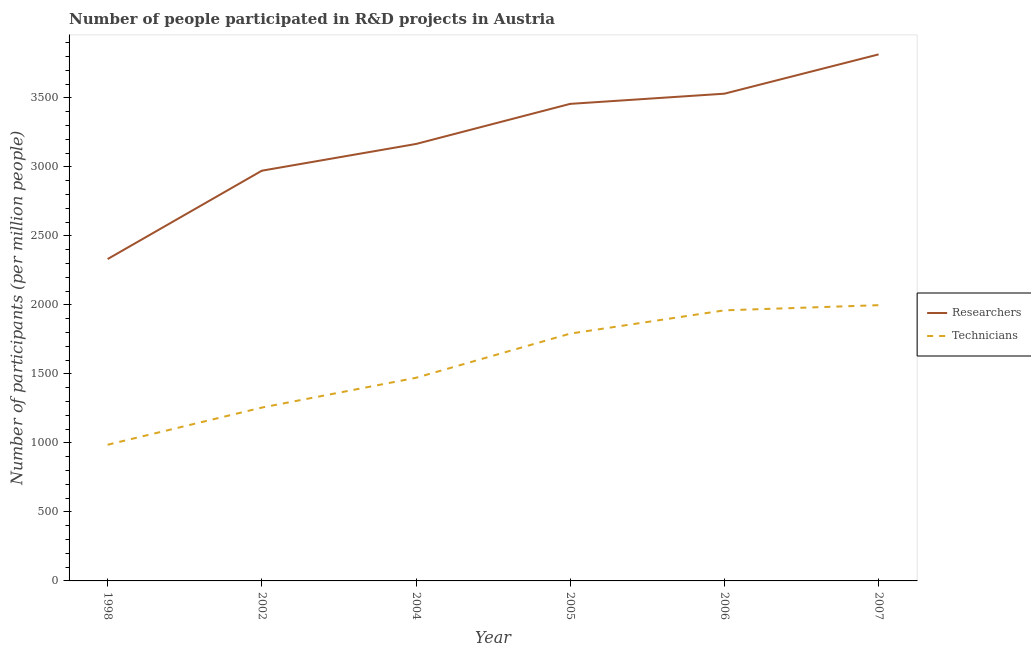Does the line corresponding to number of technicians intersect with the line corresponding to number of researchers?
Make the answer very short. No. Is the number of lines equal to the number of legend labels?
Your answer should be very brief. Yes. What is the number of technicians in 2004?
Your answer should be compact. 1472.18. Across all years, what is the maximum number of researchers?
Make the answer very short. 3815.74. Across all years, what is the minimum number of researchers?
Your answer should be compact. 2332.6. What is the total number of technicians in the graph?
Provide a succinct answer. 9466.98. What is the difference between the number of technicians in 2004 and that in 2006?
Keep it short and to the point. -488.71. What is the difference between the number of technicians in 2004 and the number of researchers in 1998?
Offer a very short reply. -860.42. What is the average number of technicians per year?
Keep it short and to the point. 1577.83. In the year 2005, what is the difference between the number of technicians and number of researchers?
Your answer should be very brief. -1664.84. What is the ratio of the number of researchers in 1998 to that in 2007?
Offer a very short reply. 0.61. Is the number of researchers in 1998 less than that in 2004?
Your answer should be compact. Yes. Is the difference between the number of researchers in 2002 and 2004 greater than the difference between the number of technicians in 2002 and 2004?
Give a very brief answer. Yes. What is the difference between the highest and the second highest number of technicians?
Your answer should be compact. 37.42. What is the difference between the highest and the lowest number of researchers?
Keep it short and to the point. 1483.15. In how many years, is the number of technicians greater than the average number of technicians taken over all years?
Keep it short and to the point. 3. Is the sum of the number of technicians in 2005 and 2006 greater than the maximum number of researchers across all years?
Offer a very short reply. No. Is the number of technicians strictly less than the number of researchers over the years?
Your response must be concise. Yes. How many lines are there?
Your answer should be very brief. 2. How many years are there in the graph?
Offer a very short reply. 6. What is the difference between two consecutive major ticks on the Y-axis?
Provide a succinct answer. 500. Does the graph contain any zero values?
Your answer should be compact. No. Does the graph contain grids?
Keep it short and to the point. No. Where does the legend appear in the graph?
Give a very brief answer. Center right. What is the title of the graph?
Your response must be concise. Number of people participated in R&D projects in Austria. Does "State government" appear as one of the legend labels in the graph?
Your response must be concise. No. What is the label or title of the X-axis?
Give a very brief answer. Year. What is the label or title of the Y-axis?
Make the answer very short. Number of participants (per million people). What is the Number of participants (per million people) of Researchers in 1998?
Provide a succinct answer. 2332.6. What is the Number of participants (per million people) of Technicians in 1998?
Offer a terse response. 987.02. What is the Number of participants (per million people) of Researchers in 2002?
Give a very brief answer. 2972.89. What is the Number of participants (per million people) in Technicians in 2002?
Ensure brevity in your answer.  1256.23. What is the Number of participants (per million people) in Researchers in 2004?
Your answer should be compact. 3166.57. What is the Number of participants (per million people) in Technicians in 2004?
Provide a succinct answer. 1472.18. What is the Number of participants (per million people) of Researchers in 2005?
Keep it short and to the point. 3457.21. What is the Number of participants (per million people) in Technicians in 2005?
Your answer should be compact. 1792.36. What is the Number of participants (per million people) of Researchers in 2006?
Keep it short and to the point. 3530.95. What is the Number of participants (per million people) in Technicians in 2006?
Provide a succinct answer. 1960.89. What is the Number of participants (per million people) of Researchers in 2007?
Your answer should be very brief. 3815.74. What is the Number of participants (per million people) in Technicians in 2007?
Make the answer very short. 1998.31. Across all years, what is the maximum Number of participants (per million people) of Researchers?
Offer a very short reply. 3815.74. Across all years, what is the maximum Number of participants (per million people) in Technicians?
Give a very brief answer. 1998.31. Across all years, what is the minimum Number of participants (per million people) in Researchers?
Offer a terse response. 2332.6. Across all years, what is the minimum Number of participants (per million people) of Technicians?
Provide a succinct answer. 987.02. What is the total Number of participants (per million people) of Researchers in the graph?
Your response must be concise. 1.93e+04. What is the total Number of participants (per million people) in Technicians in the graph?
Provide a succinct answer. 9466.98. What is the difference between the Number of participants (per million people) in Researchers in 1998 and that in 2002?
Offer a terse response. -640.29. What is the difference between the Number of participants (per million people) in Technicians in 1998 and that in 2002?
Offer a very short reply. -269.21. What is the difference between the Number of participants (per million people) of Researchers in 1998 and that in 2004?
Give a very brief answer. -833.98. What is the difference between the Number of participants (per million people) in Technicians in 1998 and that in 2004?
Make the answer very short. -485.16. What is the difference between the Number of participants (per million people) in Researchers in 1998 and that in 2005?
Your answer should be very brief. -1124.61. What is the difference between the Number of participants (per million people) of Technicians in 1998 and that in 2005?
Your answer should be very brief. -805.34. What is the difference between the Number of participants (per million people) in Researchers in 1998 and that in 2006?
Make the answer very short. -1198.35. What is the difference between the Number of participants (per million people) of Technicians in 1998 and that in 2006?
Provide a short and direct response. -973.87. What is the difference between the Number of participants (per million people) in Researchers in 1998 and that in 2007?
Keep it short and to the point. -1483.15. What is the difference between the Number of participants (per million people) of Technicians in 1998 and that in 2007?
Provide a short and direct response. -1011.29. What is the difference between the Number of participants (per million people) in Researchers in 2002 and that in 2004?
Your answer should be very brief. -193.68. What is the difference between the Number of participants (per million people) in Technicians in 2002 and that in 2004?
Keep it short and to the point. -215.95. What is the difference between the Number of participants (per million people) of Researchers in 2002 and that in 2005?
Provide a succinct answer. -484.32. What is the difference between the Number of participants (per million people) in Technicians in 2002 and that in 2005?
Offer a terse response. -536.13. What is the difference between the Number of participants (per million people) of Researchers in 2002 and that in 2006?
Keep it short and to the point. -558.06. What is the difference between the Number of participants (per million people) in Technicians in 2002 and that in 2006?
Make the answer very short. -704.66. What is the difference between the Number of participants (per million people) in Researchers in 2002 and that in 2007?
Give a very brief answer. -842.85. What is the difference between the Number of participants (per million people) in Technicians in 2002 and that in 2007?
Offer a very short reply. -742.08. What is the difference between the Number of participants (per million people) of Researchers in 2004 and that in 2005?
Provide a short and direct response. -290.63. What is the difference between the Number of participants (per million people) of Technicians in 2004 and that in 2005?
Offer a very short reply. -320.18. What is the difference between the Number of participants (per million people) in Researchers in 2004 and that in 2006?
Your response must be concise. -364.37. What is the difference between the Number of participants (per million people) of Technicians in 2004 and that in 2006?
Give a very brief answer. -488.71. What is the difference between the Number of participants (per million people) of Researchers in 2004 and that in 2007?
Your response must be concise. -649.17. What is the difference between the Number of participants (per million people) of Technicians in 2004 and that in 2007?
Provide a short and direct response. -526.13. What is the difference between the Number of participants (per million people) of Researchers in 2005 and that in 2006?
Provide a succinct answer. -73.74. What is the difference between the Number of participants (per million people) in Technicians in 2005 and that in 2006?
Keep it short and to the point. -168.53. What is the difference between the Number of participants (per million people) in Researchers in 2005 and that in 2007?
Provide a short and direct response. -358.54. What is the difference between the Number of participants (per million people) in Technicians in 2005 and that in 2007?
Give a very brief answer. -205.95. What is the difference between the Number of participants (per million people) in Researchers in 2006 and that in 2007?
Offer a terse response. -284.8. What is the difference between the Number of participants (per million people) of Technicians in 2006 and that in 2007?
Provide a short and direct response. -37.42. What is the difference between the Number of participants (per million people) in Researchers in 1998 and the Number of participants (per million people) in Technicians in 2002?
Offer a very short reply. 1076.37. What is the difference between the Number of participants (per million people) in Researchers in 1998 and the Number of participants (per million people) in Technicians in 2004?
Your answer should be compact. 860.42. What is the difference between the Number of participants (per million people) of Researchers in 1998 and the Number of participants (per million people) of Technicians in 2005?
Ensure brevity in your answer.  540.23. What is the difference between the Number of participants (per million people) of Researchers in 1998 and the Number of participants (per million people) of Technicians in 2006?
Give a very brief answer. 371.71. What is the difference between the Number of participants (per million people) in Researchers in 1998 and the Number of participants (per million people) in Technicians in 2007?
Your answer should be compact. 334.28. What is the difference between the Number of participants (per million people) in Researchers in 2002 and the Number of participants (per million people) in Technicians in 2004?
Provide a short and direct response. 1500.71. What is the difference between the Number of participants (per million people) of Researchers in 2002 and the Number of participants (per million people) of Technicians in 2005?
Keep it short and to the point. 1180.53. What is the difference between the Number of participants (per million people) in Researchers in 2002 and the Number of participants (per million people) in Technicians in 2006?
Offer a very short reply. 1012. What is the difference between the Number of participants (per million people) in Researchers in 2002 and the Number of participants (per million people) in Technicians in 2007?
Provide a short and direct response. 974.58. What is the difference between the Number of participants (per million people) of Researchers in 2004 and the Number of participants (per million people) of Technicians in 2005?
Give a very brief answer. 1374.21. What is the difference between the Number of participants (per million people) of Researchers in 2004 and the Number of participants (per million people) of Technicians in 2006?
Keep it short and to the point. 1205.68. What is the difference between the Number of participants (per million people) in Researchers in 2004 and the Number of participants (per million people) in Technicians in 2007?
Offer a very short reply. 1168.26. What is the difference between the Number of participants (per million people) of Researchers in 2005 and the Number of participants (per million people) of Technicians in 2006?
Your answer should be compact. 1496.32. What is the difference between the Number of participants (per million people) in Researchers in 2005 and the Number of participants (per million people) in Technicians in 2007?
Offer a very short reply. 1458.9. What is the difference between the Number of participants (per million people) of Researchers in 2006 and the Number of participants (per million people) of Technicians in 2007?
Make the answer very short. 1532.63. What is the average Number of participants (per million people) in Researchers per year?
Offer a terse response. 3212.66. What is the average Number of participants (per million people) in Technicians per year?
Keep it short and to the point. 1577.83. In the year 1998, what is the difference between the Number of participants (per million people) of Researchers and Number of participants (per million people) of Technicians?
Your response must be concise. 1345.58. In the year 2002, what is the difference between the Number of participants (per million people) of Researchers and Number of participants (per million people) of Technicians?
Offer a very short reply. 1716.66. In the year 2004, what is the difference between the Number of participants (per million people) in Researchers and Number of participants (per million people) in Technicians?
Your answer should be compact. 1694.39. In the year 2005, what is the difference between the Number of participants (per million people) in Researchers and Number of participants (per million people) in Technicians?
Keep it short and to the point. 1664.84. In the year 2006, what is the difference between the Number of participants (per million people) of Researchers and Number of participants (per million people) of Technicians?
Give a very brief answer. 1570.06. In the year 2007, what is the difference between the Number of participants (per million people) of Researchers and Number of participants (per million people) of Technicians?
Give a very brief answer. 1817.43. What is the ratio of the Number of participants (per million people) of Researchers in 1998 to that in 2002?
Give a very brief answer. 0.78. What is the ratio of the Number of participants (per million people) in Technicians in 1998 to that in 2002?
Keep it short and to the point. 0.79. What is the ratio of the Number of participants (per million people) of Researchers in 1998 to that in 2004?
Your answer should be very brief. 0.74. What is the ratio of the Number of participants (per million people) of Technicians in 1998 to that in 2004?
Provide a short and direct response. 0.67. What is the ratio of the Number of participants (per million people) of Researchers in 1998 to that in 2005?
Make the answer very short. 0.67. What is the ratio of the Number of participants (per million people) in Technicians in 1998 to that in 2005?
Your response must be concise. 0.55. What is the ratio of the Number of participants (per million people) of Researchers in 1998 to that in 2006?
Keep it short and to the point. 0.66. What is the ratio of the Number of participants (per million people) in Technicians in 1998 to that in 2006?
Your answer should be compact. 0.5. What is the ratio of the Number of participants (per million people) of Researchers in 1998 to that in 2007?
Give a very brief answer. 0.61. What is the ratio of the Number of participants (per million people) in Technicians in 1998 to that in 2007?
Provide a succinct answer. 0.49. What is the ratio of the Number of participants (per million people) in Researchers in 2002 to that in 2004?
Keep it short and to the point. 0.94. What is the ratio of the Number of participants (per million people) of Technicians in 2002 to that in 2004?
Your answer should be very brief. 0.85. What is the ratio of the Number of participants (per million people) in Researchers in 2002 to that in 2005?
Give a very brief answer. 0.86. What is the ratio of the Number of participants (per million people) in Technicians in 2002 to that in 2005?
Keep it short and to the point. 0.7. What is the ratio of the Number of participants (per million people) in Researchers in 2002 to that in 2006?
Your response must be concise. 0.84. What is the ratio of the Number of participants (per million people) of Technicians in 2002 to that in 2006?
Your response must be concise. 0.64. What is the ratio of the Number of participants (per million people) of Researchers in 2002 to that in 2007?
Offer a terse response. 0.78. What is the ratio of the Number of participants (per million people) in Technicians in 2002 to that in 2007?
Your response must be concise. 0.63. What is the ratio of the Number of participants (per million people) in Researchers in 2004 to that in 2005?
Offer a very short reply. 0.92. What is the ratio of the Number of participants (per million people) of Technicians in 2004 to that in 2005?
Your response must be concise. 0.82. What is the ratio of the Number of participants (per million people) of Researchers in 2004 to that in 2006?
Your answer should be very brief. 0.9. What is the ratio of the Number of participants (per million people) in Technicians in 2004 to that in 2006?
Keep it short and to the point. 0.75. What is the ratio of the Number of participants (per million people) of Researchers in 2004 to that in 2007?
Keep it short and to the point. 0.83. What is the ratio of the Number of participants (per million people) of Technicians in 2004 to that in 2007?
Provide a succinct answer. 0.74. What is the ratio of the Number of participants (per million people) of Researchers in 2005 to that in 2006?
Provide a short and direct response. 0.98. What is the ratio of the Number of participants (per million people) in Technicians in 2005 to that in 2006?
Your response must be concise. 0.91. What is the ratio of the Number of participants (per million people) in Researchers in 2005 to that in 2007?
Make the answer very short. 0.91. What is the ratio of the Number of participants (per million people) in Technicians in 2005 to that in 2007?
Make the answer very short. 0.9. What is the ratio of the Number of participants (per million people) in Researchers in 2006 to that in 2007?
Ensure brevity in your answer.  0.93. What is the ratio of the Number of participants (per million people) in Technicians in 2006 to that in 2007?
Offer a very short reply. 0.98. What is the difference between the highest and the second highest Number of participants (per million people) of Researchers?
Offer a very short reply. 284.8. What is the difference between the highest and the second highest Number of participants (per million people) of Technicians?
Your answer should be very brief. 37.42. What is the difference between the highest and the lowest Number of participants (per million people) of Researchers?
Your answer should be very brief. 1483.15. What is the difference between the highest and the lowest Number of participants (per million people) of Technicians?
Offer a very short reply. 1011.29. 